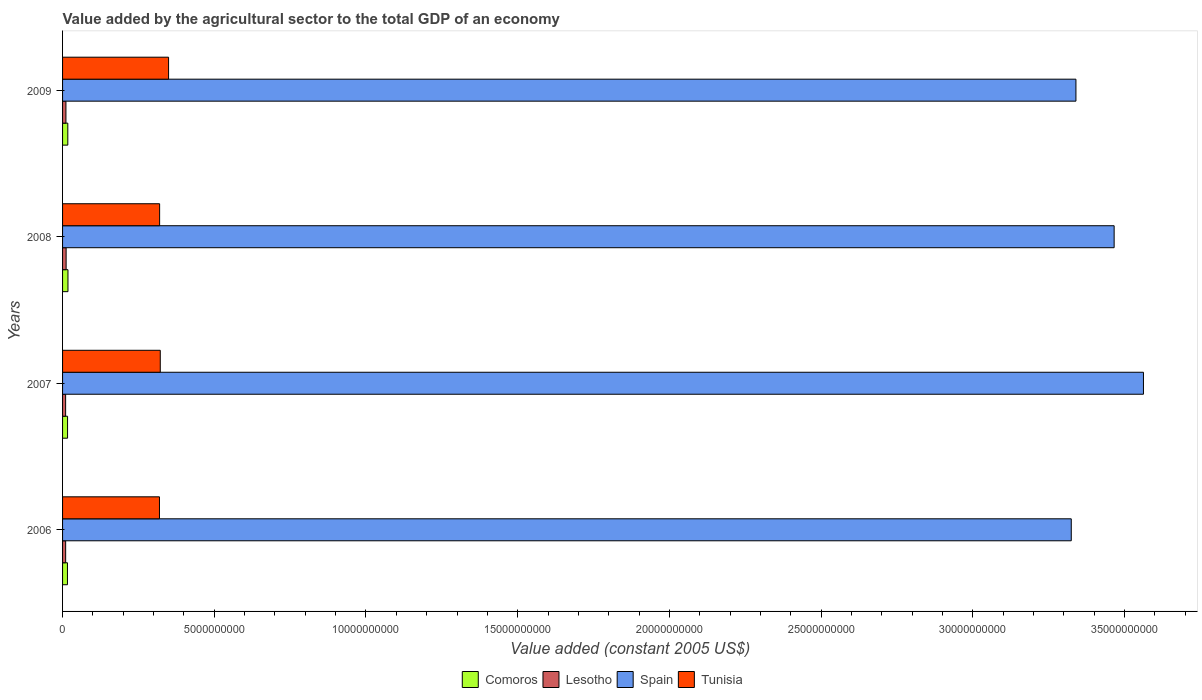Are the number of bars per tick equal to the number of legend labels?
Your response must be concise. Yes. Are the number of bars on each tick of the Y-axis equal?
Keep it short and to the point. Yes. In how many cases, is the number of bars for a given year not equal to the number of legend labels?
Your response must be concise. 0. What is the value added by the agricultural sector in Tunisia in 2006?
Make the answer very short. 3.19e+09. Across all years, what is the maximum value added by the agricultural sector in Comoros?
Make the answer very short. 1.78e+08. Across all years, what is the minimum value added by the agricultural sector in Lesotho?
Your response must be concise. 1.01e+08. In which year was the value added by the agricultural sector in Spain minimum?
Your answer should be very brief. 2006. What is the total value added by the agricultural sector in Tunisia in the graph?
Offer a very short reply. 1.31e+1. What is the difference between the value added by the agricultural sector in Comoros in 2006 and that in 2007?
Your answer should be compact. -3.71e+06. What is the difference between the value added by the agricultural sector in Spain in 2006 and the value added by the agricultural sector in Comoros in 2007?
Your answer should be very brief. 3.31e+1. What is the average value added by the agricultural sector in Spain per year?
Your answer should be compact. 3.42e+1. In the year 2009, what is the difference between the value added by the agricultural sector in Comoros and value added by the agricultural sector in Lesotho?
Ensure brevity in your answer.  6.16e+07. In how many years, is the value added by the agricultural sector in Tunisia greater than 25000000000 US$?
Your answer should be very brief. 0. What is the ratio of the value added by the agricultural sector in Comoros in 2007 to that in 2008?
Your answer should be compact. 0.92. Is the difference between the value added by the agricultural sector in Comoros in 2007 and 2008 greater than the difference between the value added by the agricultural sector in Lesotho in 2007 and 2008?
Your answer should be compact. Yes. What is the difference between the highest and the second highest value added by the agricultural sector in Lesotho?
Provide a succinct answer. 5.93e+06. What is the difference between the highest and the lowest value added by the agricultural sector in Comoros?
Your response must be concise. 1.74e+07. What does the 1st bar from the top in 2008 represents?
Provide a short and direct response. Tunisia. What does the 2nd bar from the bottom in 2007 represents?
Offer a very short reply. Lesotho. Are all the bars in the graph horizontal?
Your answer should be very brief. Yes. How many years are there in the graph?
Ensure brevity in your answer.  4. What is the difference between two consecutive major ticks on the X-axis?
Provide a short and direct response. 5.00e+09. Are the values on the major ticks of X-axis written in scientific E-notation?
Offer a very short reply. No. Does the graph contain any zero values?
Ensure brevity in your answer.  No. Where does the legend appear in the graph?
Offer a very short reply. Bottom center. How are the legend labels stacked?
Offer a terse response. Horizontal. What is the title of the graph?
Provide a short and direct response. Value added by the agricultural sector to the total GDP of an economy. Does "Solomon Islands" appear as one of the legend labels in the graph?
Offer a very short reply. No. What is the label or title of the X-axis?
Make the answer very short. Value added (constant 2005 US$). What is the Value added (constant 2005 US$) in Comoros in 2006?
Ensure brevity in your answer.  1.61e+08. What is the Value added (constant 2005 US$) of Lesotho in 2006?
Keep it short and to the point. 1.02e+08. What is the Value added (constant 2005 US$) in Spain in 2006?
Ensure brevity in your answer.  3.32e+1. What is the Value added (constant 2005 US$) in Tunisia in 2006?
Make the answer very short. 3.19e+09. What is the Value added (constant 2005 US$) of Comoros in 2007?
Your answer should be very brief. 1.65e+08. What is the Value added (constant 2005 US$) of Lesotho in 2007?
Make the answer very short. 1.01e+08. What is the Value added (constant 2005 US$) in Spain in 2007?
Ensure brevity in your answer.  3.56e+1. What is the Value added (constant 2005 US$) in Tunisia in 2007?
Your answer should be compact. 3.22e+09. What is the Value added (constant 2005 US$) in Comoros in 2008?
Offer a very short reply. 1.78e+08. What is the Value added (constant 2005 US$) of Lesotho in 2008?
Ensure brevity in your answer.  1.17e+08. What is the Value added (constant 2005 US$) in Spain in 2008?
Provide a succinct answer. 3.47e+1. What is the Value added (constant 2005 US$) of Tunisia in 2008?
Give a very brief answer. 3.20e+09. What is the Value added (constant 2005 US$) in Comoros in 2009?
Provide a short and direct response. 1.73e+08. What is the Value added (constant 2005 US$) in Lesotho in 2009?
Provide a short and direct response. 1.11e+08. What is the Value added (constant 2005 US$) of Spain in 2009?
Your answer should be compact. 3.34e+1. What is the Value added (constant 2005 US$) of Tunisia in 2009?
Your answer should be very brief. 3.49e+09. Across all years, what is the maximum Value added (constant 2005 US$) in Comoros?
Provide a succinct answer. 1.78e+08. Across all years, what is the maximum Value added (constant 2005 US$) in Lesotho?
Provide a short and direct response. 1.17e+08. Across all years, what is the maximum Value added (constant 2005 US$) in Spain?
Your response must be concise. 3.56e+1. Across all years, what is the maximum Value added (constant 2005 US$) of Tunisia?
Your answer should be very brief. 3.49e+09. Across all years, what is the minimum Value added (constant 2005 US$) in Comoros?
Your response must be concise. 1.61e+08. Across all years, what is the minimum Value added (constant 2005 US$) in Lesotho?
Your response must be concise. 1.01e+08. Across all years, what is the minimum Value added (constant 2005 US$) of Spain?
Ensure brevity in your answer.  3.32e+1. Across all years, what is the minimum Value added (constant 2005 US$) of Tunisia?
Your response must be concise. 3.19e+09. What is the total Value added (constant 2005 US$) in Comoros in the graph?
Your answer should be very brief. 6.77e+08. What is the total Value added (constant 2005 US$) of Lesotho in the graph?
Ensure brevity in your answer.  4.31e+08. What is the total Value added (constant 2005 US$) of Spain in the graph?
Make the answer very short. 1.37e+11. What is the total Value added (constant 2005 US$) of Tunisia in the graph?
Your response must be concise. 1.31e+1. What is the difference between the Value added (constant 2005 US$) of Comoros in 2006 and that in 2007?
Your answer should be very brief. -3.71e+06. What is the difference between the Value added (constant 2005 US$) of Lesotho in 2006 and that in 2007?
Offer a very short reply. 9.36e+05. What is the difference between the Value added (constant 2005 US$) in Spain in 2006 and that in 2007?
Keep it short and to the point. -2.38e+09. What is the difference between the Value added (constant 2005 US$) in Tunisia in 2006 and that in 2007?
Offer a very short reply. -2.64e+07. What is the difference between the Value added (constant 2005 US$) in Comoros in 2006 and that in 2008?
Your answer should be compact. -1.74e+07. What is the difference between the Value added (constant 2005 US$) in Lesotho in 2006 and that in 2008?
Provide a succinct answer. -1.54e+07. What is the difference between the Value added (constant 2005 US$) of Spain in 2006 and that in 2008?
Your answer should be compact. -1.41e+09. What is the difference between the Value added (constant 2005 US$) in Tunisia in 2006 and that in 2008?
Make the answer very short. -5.25e+06. What is the difference between the Value added (constant 2005 US$) of Comoros in 2006 and that in 2009?
Make the answer very short. -1.18e+07. What is the difference between the Value added (constant 2005 US$) of Lesotho in 2006 and that in 2009?
Your answer should be very brief. -9.45e+06. What is the difference between the Value added (constant 2005 US$) in Spain in 2006 and that in 2009?
Ensure brevity in your answer.  -1.54e+08. What is the difference between the Value added (constant 2005 US$) of Tunisia in 2006 and that in 2009?
Offer a terse response. -3.00e+08. What is the difference between the Value added (constant 2005 US$) in Comoros in 2007 and that in 2008?
Offer a terse response. -1.37e+07. What is the difference between the Value added (constant 2005 US$) in Lesotho in 2007 and that in 2008?
Offer a very short reply. -1.63e+07. What is the difference between the Value added (constant 2005 US$) in Spain in 2007 and that in 2008?
Your answer should be compact. 9.66e+08. What is the difference between the Value added (constant 2005 US$) in Tunisia in 2007 and that in 2008?
Provide a succinct answer. 2.12e+07. What is the difference between the Value added (constant 2005 US$) of Comoros in 2007 and that in 2009?
Give a very brief answer. -8.09e+06. What is the difference between the Value added (constant 2005 US$) in Lesotho in 2007 and that in 2009?
Give a very brief answer. -1.04e+07. What is the difference between the Value added (constant 2005 US$) in Spain in 2007 and that in 2009?
Keep it short and to the point. 2.22e+09. What is the difference between the Value added (constant 2005 US$) in Tunisia in 2007 and that in 2009?
Give a very brief answer. -2.74e+08. What is the difference between the Value added (constant 2005 US$) in Comoros in 2008 and that in 2009?
Offer a terse response. 5.60e+06. What is the difference between the Value added (constant 2005 US$) in Lesotho in 2008 and that in 2009?
Provide a succinct answer. 5.93e+06. What is the difference between the Value added (constant 2005 US$) of Spain in 2008 and that in 2009?
Provide a short and direct response. 1.26e+09. What is the difference between the Value added (constant 2005 US$) in Tunisia in 2008 and that in 2009?
Provide a short and direct response. -2.95e+08. What is the difference between the Value added (constant 2005 US$) in Comoros in 2006 and the Value added (constant 2005 US$) in Lesotho in 2007?
Your answer should be very brief. 6.01e+07. What is the difference between the Value added (constant 2005 US$) of Comoros in 2006 and the Value added (constant 2005 US$) of Spain in 2007?
Your response must be concise. -3.55e+1. What is the difference between the Value added (constant 2005 US$) of Comoros in 2006 and the Value added (constant 2005 US$) of Tunisia in 2007?
Ensure brevity in your answer.  -3.06e+09. What is the difference between the Value added (constant 2005 US$) in Lesotho in 2006 and the Value added (constant 2005 US$) in Spain in 2007?
Your answer should be compact. -3.55e+1. What is the difference between the Value added (constant 2005 US$) in Lesotho in 2006 and the Value added (constant 2005 US$) in Tunisia in 2007?
Give a very brief answer. -3.12e+09. What is the difference between the Value added (constant 2005 US$) of Spain in 2006 and the Value added (constant 2005 US$) of Tunisia in 2007?
Offer a very short reply. 3.00e+1. What is the difference between the Value added (constant 2005 US$) of Comoros in 2006 and the Value added (constant 2005 US$) of Lesotho in 2008?
Offer a very short reply. 4.38e+07. What is the difference between the Value added (constant 2005 US$) in Comoros in 2006 and the Value added (constant 2005 US$) in Spain in 2008?
Your answer should be very brief. -3.45e+1. What is the difference between the Value added (constant 2005 US$) of Comoros in 2006 and the Value added (constant 2005 US$) of Tunisia in 2008?
Provide a short and direct response. -3.04e+09. What is the difference between the Value added (constant 2005 US$) of Lesotho in 2006 and the Value added (constant 2005 US$) of Spain in 2008?
Offer a very short reply. -3.46e+1. What is the difference between the Value added (constant 2005 US$) in Lesotho in 2006 and the Value added (constant 2005 US$) in Tunisia in 2008?
Your response must be concise. -3.10e+09. What is the difference between the Value added (constant 2005 US$) in Spain in 2006 and the Value added (constant 2005 US$) in Tunisia in 2008?
Your answer should be very brief. 3.00e+1. What is the difference between the Value added (constant 2005 US$) of Comoros in 2006 and the Value added (constant 2005 US$) of Lesotho in 2009?
Offer a terse response. 4.98e+07. What is the difference between the Value added (constant 2005 US$) of Comoros in 2006 and the Value added (constant 2005 US$) of Spain in 2009?
Your answer should be compact. -3.32e+1. What is the difference between the Value added (constant 2005 US$) of Comoros in 2006 and the Value added (constant 2005 US$) of Tunisia in 2009?
Your answer should be very brief. -3.33e+09. What is the difference between the Value added (constant 2005 US$) in Lesotho in 2006 and the Value added (constant 2005 US$) in Spain in 2009?
Provide a short and direct response. -3.33e+1. What is the difference between the Value added (constant 2005 US$) of Lesotho in 2006 and the Value added (constant 2005 US$) of Tunisia in 2009?
Offer a very short reply. -3.39e+09. What is the difference between the Value added (constant 2005 US$) of Spain in 2006 and the Value added (constant 2005 US$) of Tunisia in 2009?
Your answer should be compact. 2.98e+1. What is the difference between the Value added (constant 2005 US$) in Comoros in 2007 and the Value added (constant 2005 US$) in Lesotho in 2008?
Make the answer very short. 4.75e+07. What is the difference between the Value added (constant 2005 US$) in Comoros in 2007 and the Value added (constant 2005 US$) in Spain in 2008?
Offer a very short reply. -3.45e+1. What is the difference between the Value added (constant 2005 US$) in Comoros in 2007 and the Value added (constant 2005 US$) in Tunisia in 2008?
Provide a succinct answer. -3.03e+09. What is the difference between the Value added (constant 2005 US$) in Lesotho in 2007 and the Value added (constant 2005 US$) in Spain in 2008?
Make the answer very short. -3.46e+1. What is the difference between the Value added (constant 2005 US$) of Lesotho in 2007 and the Value added (constant 2005 US$) of Tunisia in 2008?
Keep it short and to the point. -3.10e+09. What is the difference between the Value added (constant 2005 US$) of Spain in 2007 and the Value added (constant 2005 US$) of Tunisia in 2008?
Your response must be concise. 3.24e+1. What is the difference between the Value added (constant 2005 US$) of Comoros in 2007 and the Value added (constant 2005 US$) of Lesotho in 2009?
Provide a succinct answer. 5.35e+07. What is the difference between the Value added (constant 2005 US$) in Comoros in 2007 and the Value added (constant 2005 US$) in Spain in 2009?
Give a very brief answer. -3.32e+1. What is the difference between the Value added (constant 2005 US$) in Comoros in 2007 and the Value added (constant 2005 US$) in Tunisia in 2009?
Provide a short and direct response. -3.33e+09. What is the difference between the Value added (constant 2005 US$) in Lesotho in 2007 and the Value added (constant 2005 US$) in Spain in 2009?
Your answer should be very brief. -3.33e+1. What is the difference between the Value added (constant 2005 US$) in Lesotho in 2007 and the Value added (constant 2005 US$) in Tunisia in 2009?
Offer a very short reply. -3.39e+09. What is the difference between the Value added (constant 2005 US$) of Spain in 2007 and the Value added (constant 2005 US$) of Tunisia in 2009?
Your answer should be very brief. 3.21e+1. What is the difference between the Value added (constant 2005 US$) of Comoros in 2008 and the Value added (constant 2005 US$) of Lesotho in 2009?
Your answer should be compact. 6.72e+07. What is the difference between the Value added (constant 2005 US$) of Comoros in 2008 and the Value added (constant 2005 US$) of Spain in 2009?
Your response must be concise. -3.32e+1. What is the difference between the Value added (constant 2005 US$) in Comoros in 2008 and the Value added (constant 2005 US$) in Tunisia in 2009?
Offer a very short reply. -3.32e+09. What is the difference between the Value added (constant 2005 US$) of Lesotho in 2008 and the Value added (constant 2005 US$) of Spain in 2009?
Offer a very short reply. -3.33e+1. What is the difference between the Value added (constant 2005 US$) in Lesotho in 2008 and the Value added (constant 2005 US$) in Tunisia in 2009?
Make the answer very short. -3.38e+09. What is the difference between the Value added (constant 2005 US$) in Spain in 2008 and the Value added (constant 2005 US$) in Tunisia in 2009?
Offer a very short reply. 3.12e+1. What is the average Value added (constant 2005 US$) in Comoros per year?
Provide a short and direct response. 1.69e+08. What is the average Value added (constant 2005 US$) of Lesotho per year?
Offer a very short reply. 1.08e+08. What is the average Value added (constant 2005 US$) of Spain per year?
Your response must be concise. 3.42e+1. What is the average Value added (constant 2005 US$) in Tunisia per year?
Provide a succinct answer. 3.28e+09. In the year 2006, what is the difference between the Value added (constant 2005 US$) of Comoros and Value added (constant 2005 US$) of Lesotho?
Give a very brief answer. 5.92e+07. In the year 2006, what is the difference between the Value added (constant 2005 US$) in Comoros and Value added (constant 2005 US$) in Spain?
Offer a very short reply. -3.31e+1. In the year 2006, what is the difference between the Value added (constant 2005 US$) in Comoros and Value added (constant 2005 US$) in Tunisia?
Your answer should be very brief. -3.03e+09. In the year 2006, what is the difference between the Value added (constant 2005 US$) in Lesotho and Value added (constant 2005 US$) in Spain?
Your answer should be very brief. -3.31e+1. In the year 2006, what is the difference between the Value added (constant 2005 US$) in Lesotho and Value added (constant 2005 US$) in Tunisia?
Offer a terse response. -3.09e+09. In the year 2006, what is the difference between the Value added (constant 2005 US$) of Spain and Value added (constant 2005 US$) of Tunisia?
Provide a short and direct response. 3.01e+1. In the year 2007, what is the difference between the Value added (constant 2005 US$) in Comoros and Value added (constant 2005 US$) in Lesotho?
Keep it short and to the point. 6.39e+07. In the year 2007, what is the difference between the Value added (constant 2005 US$) of Comoros and Value added (constant 2005 US$) of Spain?
Your response must be concise. -3.55e+1. In the year 2007, what is the difference between the Value added (constant 2005 US$) in Comoros and Value added (constant 2005 US$) in Tunisia?
Keep it short and to the point. -3.06e+09. In the year 2007, what is the difference between the Value added (constant 2005 US$) of Lesotho and Value added (constant 2005 US$) of Spain?
Offer a terse response. -3.55e+1. In the year 2007, what is the difference between the Value added (constant 2005 US$) of Lesotho and Value added (constant 2005 US$) of Tunisia?
Give a very brief answer. -3.12e+09. In the year 2007, what is the difference between the Value added (constant 2005 US$) in Spain and Value added (constant 2005 US$) in Tunisia?
Keep it short and to the point. 3.24e+1. In the year 2008, what is the difference between the Value added (constant 2005 US$) in Comoros and Value added (constant 2005 US$) in Lesotho?
Provide a short and direct response. 6.12e+07. In the year 2008, what is the difference between the Value added (constant 2005 US$) of Comoros and Value added (constant 2005 US$) of Spain?
Keep it short and to the point. -3.45e+1. In the year 2008, what is the difference between the Value added (constant 2005 US$) of Comoros and Value added (constant 2005 US$) of Tunisia?
Offer a very short reply. -3.02e+09. In the year 2008, what is the difference between the Value added (constant 2005 US$) of Lesotho and Value added (constant 2005 US$) of Spain?
Keep it short and to the point. -3.45e+1. In the year 2008, what is the difference between the Value added (constant 2005 US$) of Lesotho and Value added (constant 2005 US$) of Tunisia?
Ensure brevity in your answer.  -3.08e+09. In the year 2008, what is the difference between the Value added (constant 2005 US$) of Spain and Value added (constant 2005 US$) of Tunisia?
Your answer should be compact. 3.15e+1. In the year 2009, what is the difference between the Value added (constant 2005 US$) of Comoros and Value added (constant 2005 US$) of Lesotho?
Give a very brief answer. 6.16e+07. In the year 2009, what is the difference between the Value added (constant 2005 US$) of Comoros and Value added (constant 2005 US$) of Spain?
Offer a terse response. -3.32e+1. In the year 2009, what is the difference between the Value added (constant 2005 US$) in Comoros and Value added (constant 2005 US$) in Tunisia?
Provide a short and direct response. -3.32e+09. In the year 2009, what is the difference between the Value added (constant 2005 US$) in Lesotho and Value added (constant 2005 US$) in Spain?
Make the answer very short. -3.33e+1. In the year 2009, what is the difference between the Value added (constant 2005 US$) of Lesotho and Value added (constant 2005 US$) of Tunisia?
Ensure brevity in your answer.  -3.38e+09. In the year 2009, what is the difference between the Value added (constant 2005 US$) of Spain and Value added (constant 2005 US$) of Tunisia?
Keep it short and to the point. 2.99e+1. What is the ratio of the Value added (constant 2005 US$) of Comoros in 2006 to that in 2007?
Your answer should be compact. 0.98. What is the ratio of the Value added (constant 2005 US$) of Lesotho in 2006 to that in 2007?
Keep it short and to the point. 1.01. What is the ratio of the Value added (constant 2005 US$) of Spain in 2006 to that in 2007?
Keep it short and to the point. 0.93. What is the ratio of the Value added (constant 2005 US$) of Tunisia in 2006 to that in 2007?
Ensure brevity in your answer.  0.99. What is the ratio of the Value added (constant 2005 US$) of Comoros in 2006 to that in 2008?
Offer a very short reply. 0.9. What is the ratio of the Value added (constant 2005 US$) of Lesotho in 2006 to that in 2008?
Give a very brief answer. 0.87. What is the ratio of the Value added (constant 2005 US$) in Spain in 2006 to that in 2008?
Ensure brevity in your answer.  0.96. What is the ratio of the Value added (constant 2005 US$) in Tunisia in 2006 to that in 2008?
Keep it short and to the point. 1. What is the ratio of the Value added (constant 2005 US$) in Comoros in 2006 to that in 2009?
Give a very brief answer. 0.93. What is the ratio of the Value added (constant 2005 US$) of Lesotho in 2006 to that in 2009?
Keep it short and to the point. 0.91. What is the ratio of the Value added (constant 2005 US$) in Spain in 2006 to that in 2009?
Give a very brief answer. 1. What is the ratio of the Value added (constant 2005 US$) of Tunisia in 2006 to that in 2009?
Keep it short and to the point. 0.91. What is the ratio of the Value added (constant 2005 US$) of Comoros in 2007 to that in 2008?
Give a very brief answer. 0.92. What is the ratio of the Value added (constant 2005 US$) of Lesotho in 2007 to that in 2008?
Provide a succinct answer. 0.86. What is the ratio of the Value added (constant 2005 US$) of Spain in 2007 to that in 2008?
Your response must be concise. 1.03. What is the ratio of the Value added (constant 2005 US$) of Tunisia in 2007 to that in 2008?
Give a very brief answer. 1.01. What is the ratio of the Value added (constant 2005 US$) of Comoros in 2007 to that in 2009?
Provide a short and direct response. 0.95. What is the ratio of the Value added (constant 2005 US$) in Lesotho in 2007 to that in 2009?
Give a very brief answer. 0.91. What is the ratio of the Value added (constant 2005 US$) of Spain in 2007 to that in 2009?
Keep it short and to the point. 1.07. What is the ratio of the Value added (constant 2005 US$) in Tunisia in 2007 to that in 2009?
Ensure brevity in your answer.  0.92. What is the ratio of the Value added (constant 2005 US$) of Comoros in 2008 to that in 2009?
Give a very brief answer. 1.03. What is the ratio of the Value added (constant 2005 US$) of Lesotho in 2008 to that in 2009?
Ensure brevity in your answer.  1.05. What is the ratio of the Value added (constant 2005 US$) in Spain in 2008 to that in 2009?
Offer a very short reply. 1.04. What is the ratio of the Value added (constant 2005 US$) in Tunisia in 2008 to that in 2009?
Provide a succinct answer. 0.92. What is the difference between the highest and the second highest Value added (constant 2005 US$) of Comoros?
Your answer should be compact. 5.60e+06. What is the difference between the highest and the second highest Value added (constant 2005 US$) in Lesotho?
Make the answer very short. 5.93e+06. What is the difference between the highest and the second highest Value added (constant 2005 US$) in Spain?
Make the answer very short. 9.66e+08. What is the difference between the highest and the second highest Value added (constant 2005 US$) in Tunisia?
Your answer should be very brief. 2.74e+08. What is the difference between the highest and the lowest Value added (constant 2005 US$) of Comoros?
Your response must be concise. 1.74e+07. What is the difference between the highest and the lowest Value added (constant 2005 US$) in Lesotho?
Offer a very short reply. 1.63e+07. What is the difference between the highest and the lowest Value added (constant 2005 US$) of Spain?
Your answer should be very brief. 2.38e+09. What is the difference between the highest and the lowest Value added (constant 2005 US$) of Tunisia?
Keep it short and to the point. 3.00e+08. 